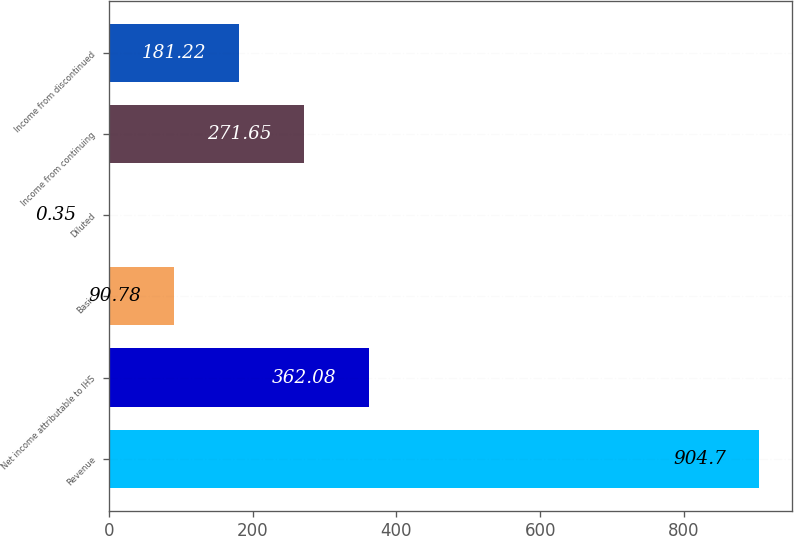<chart> <loc_0><loc_0><loc_500><loc_500><bar_chart><fcel>Revenue<fcel>Net income attributable to IHS<fcel>Basic<fcel>Diluted<fcel>Income from continuing<fcel>Income from discontinued<nl><fcel>904.7<fcel>362.08<fcel>90.78<fcel>0.35<fcel>271.65<fcel>181.22<nl></chart> 